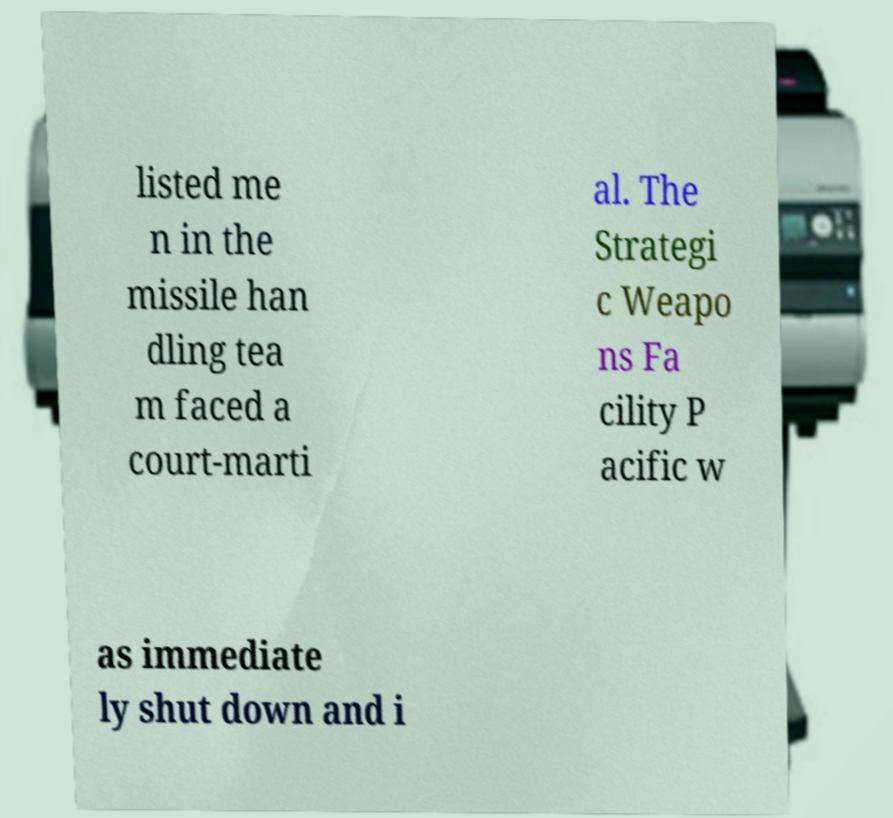Can you accurately transcribe the text from the provided image for me? listed me n in the missile han dling tea m faced a court-marti al. The Strategi c Weapo ns Fa cility P acific w as immediate ly shut down and i 